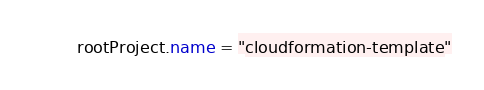<code> <loc_0><loc_0><loc_500><loc_500><_Kotlin_>rootProject.name = "cloudformation-template"
</code> 